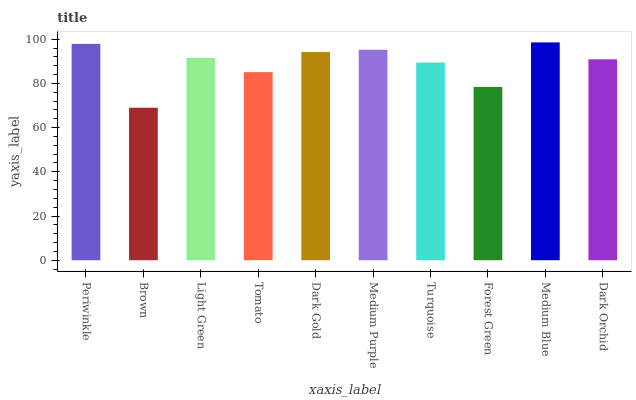Is Brown the minimum?
Answer yes or no. Yes. Is Medium Blue the maximum?
Answer yes or no. Yes. Is Light Green the minimum?
Answer yes or no. No. Is Light Green the maximum?
Answer yes or no. No. Is Light Green greater than Brown?
Answer yes or no. Yes. Is Brown less than Light Green?
Answer yes or no. Yes. Is Brown greater than Light Green?
Answer yes or no. No. Is Light Green less than Brown?
Answer yes or no. No. Is Light Green the high median?
Answer yes or no. Yes. Is Dark Orchid the low median?
Answer yes or no. Yes. Is Tomato the high median?
Answer yes or no. No. Is Light Green the low median?
Answer yes or no. No. 